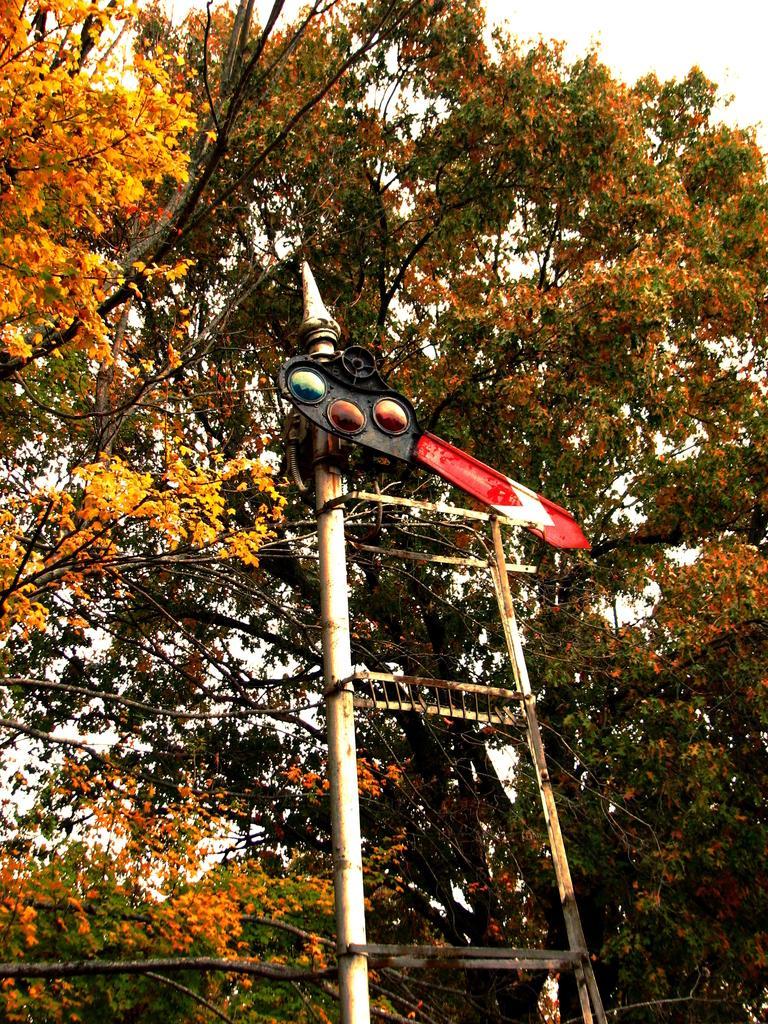Describe this image in one or two sentences. In this image there is a pole, in the background there are trees. 